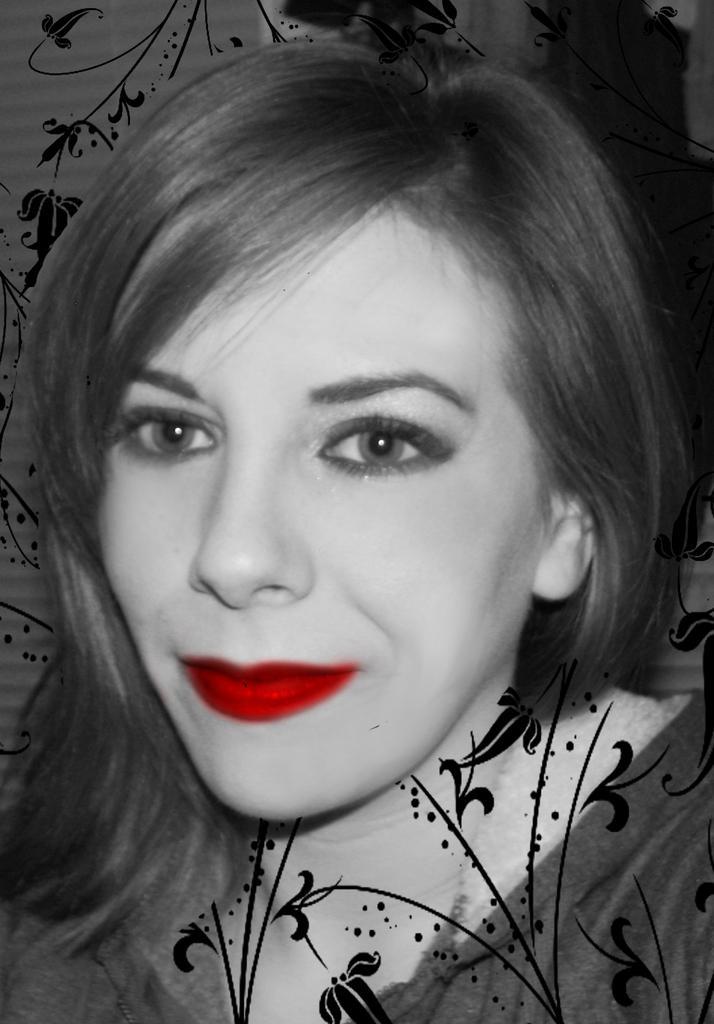How would you summarize this image in a sentence or two? This is an edited image. In this image, we can see a woman. In the background, we can see a painting. 